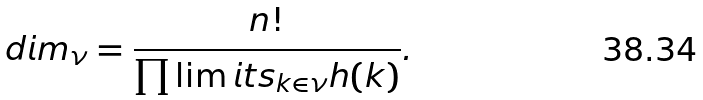<formula> <loc_0><loc_0><loc_500><loc_500>d i m _ { \nu } = \frac { n ! } { \prod \lim i t s _ { k \in \nu } h ( k ) } .</formula> 